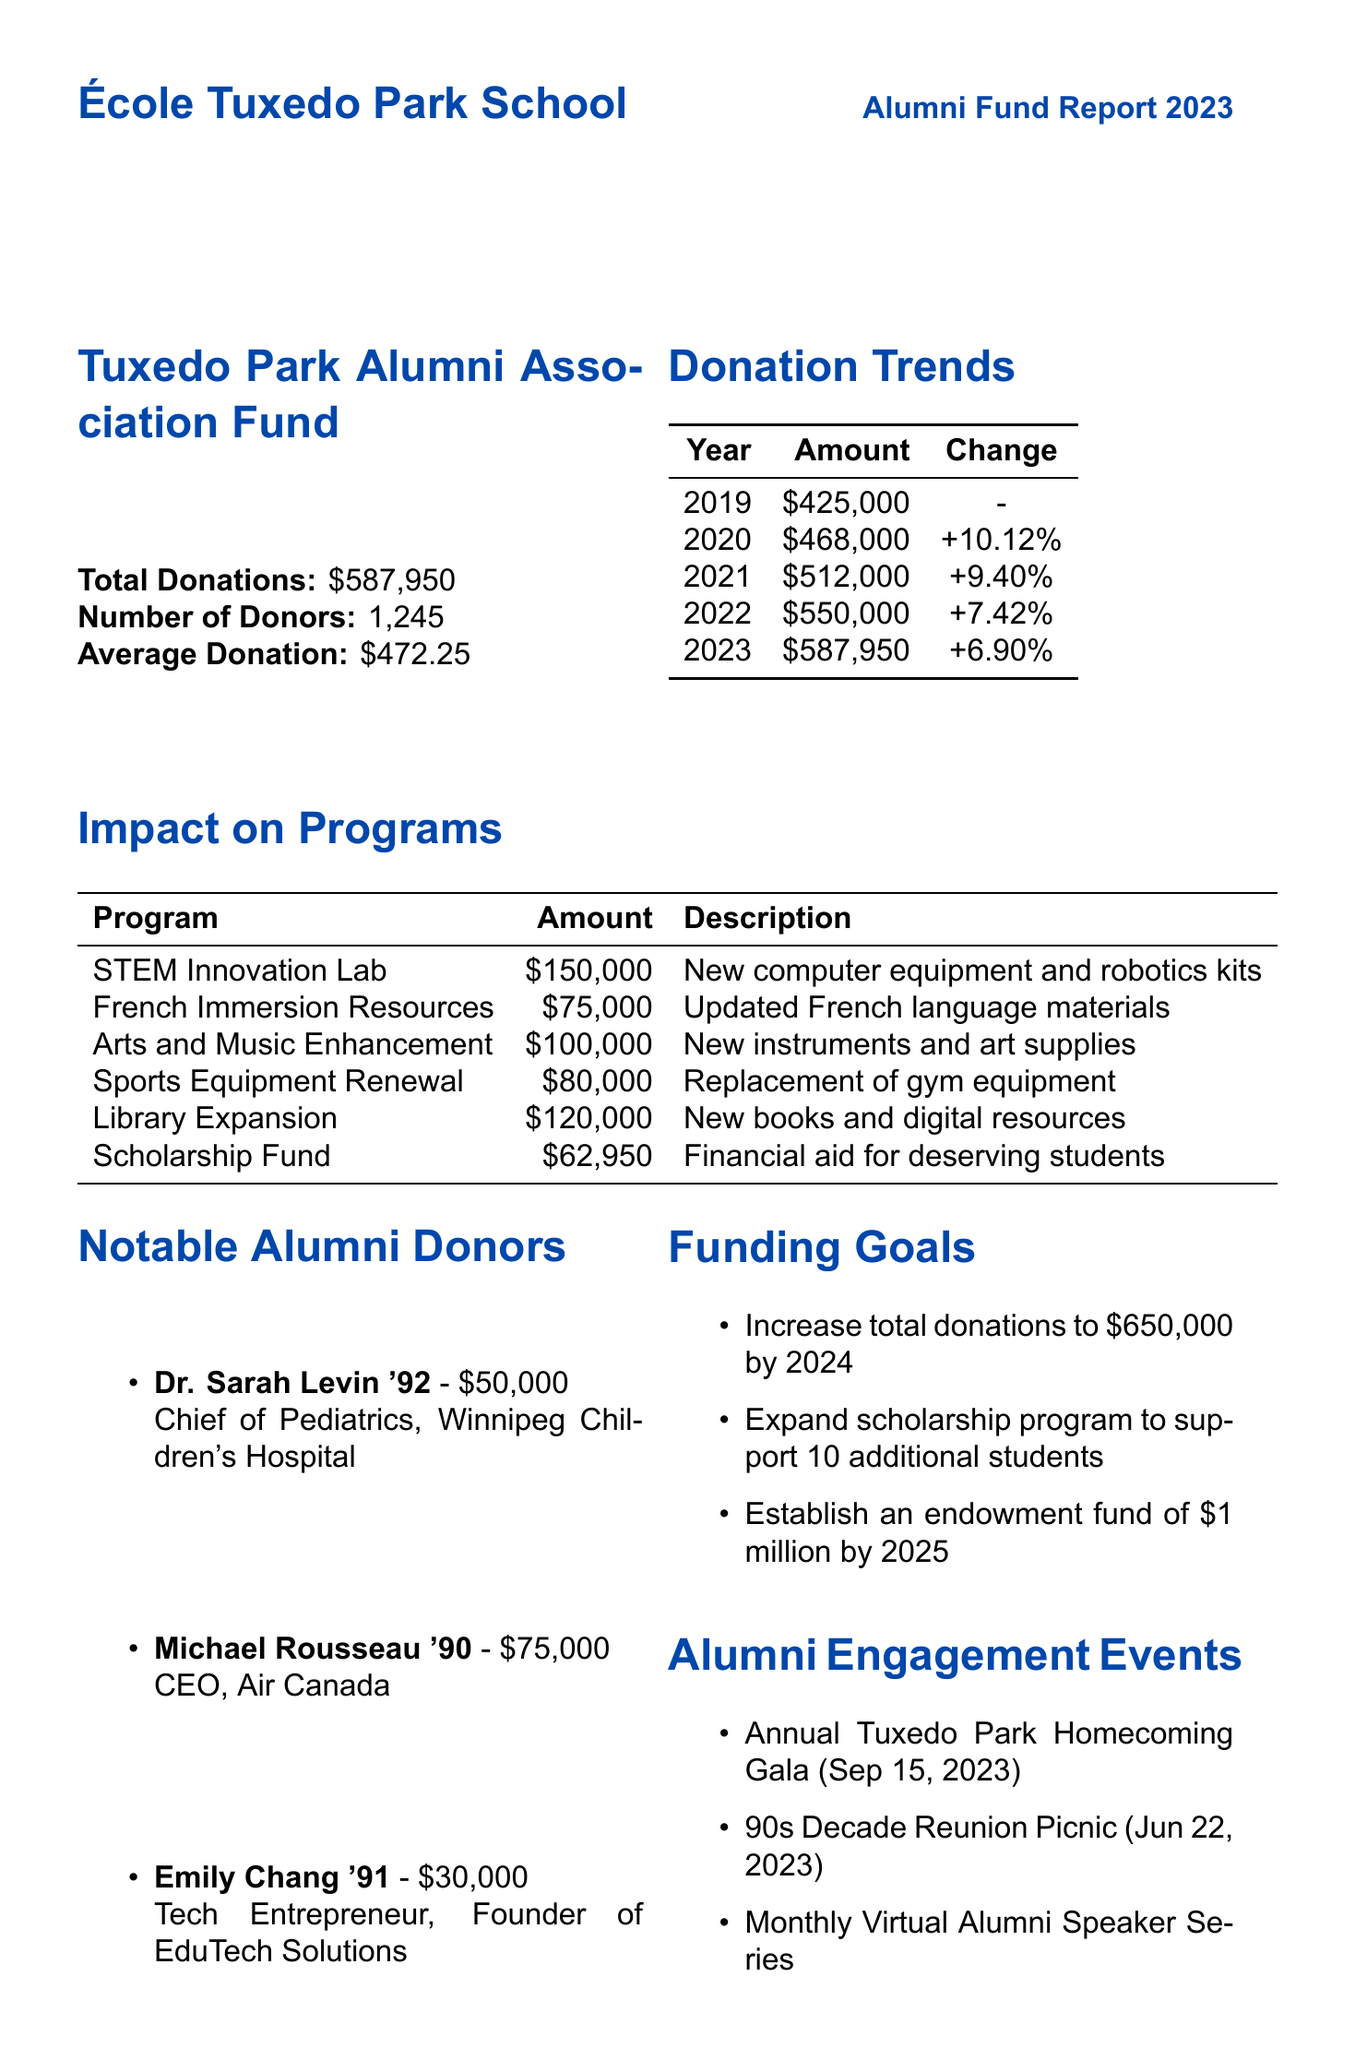what was the total amount of donations in 2023? The total donations in 2023 is explicitly stated in the document.
Answer: $587,950 how many donors contributed to the alumni fund? The number of donors is specified in the report.
Answer: 1,245 what percentage increase in donations occurred from 2022 to 2023? The percentage change from 2022 to 2023 is mentioned in the donation trends section.
Answer: 6.90% which program received the highest allocation amount? The program with the highest funding amount is noted in the impact on programs section.
Answer: STEM Innovation Lab who is the notable donor from the class of 1990? The notable alumni donors section lists contributors with their graduation years.
Answer: Michael Rousseau what is the funding goal for total donations by 2024? The funding goals section outlines the target amount for total donations by 2024.
Answer: $650,000 how much was raised at the Annual Tuxedo Park Homecoming Gala? The amount raised at the gala is recorded in the alumni engagement events part of the report.
Answer: $85,000 what decade saw the highest total donations prior to the 2020s? The donations by decade section reflects cumulative donations before the 2020s.
Answer: 1990s what is the strategy for expanding the scholarship program? Funding goals include strategies for achieving specific objectives, including scholarships.
Answer: Allocate 15% of all unrestricted donations to scholarship fund 